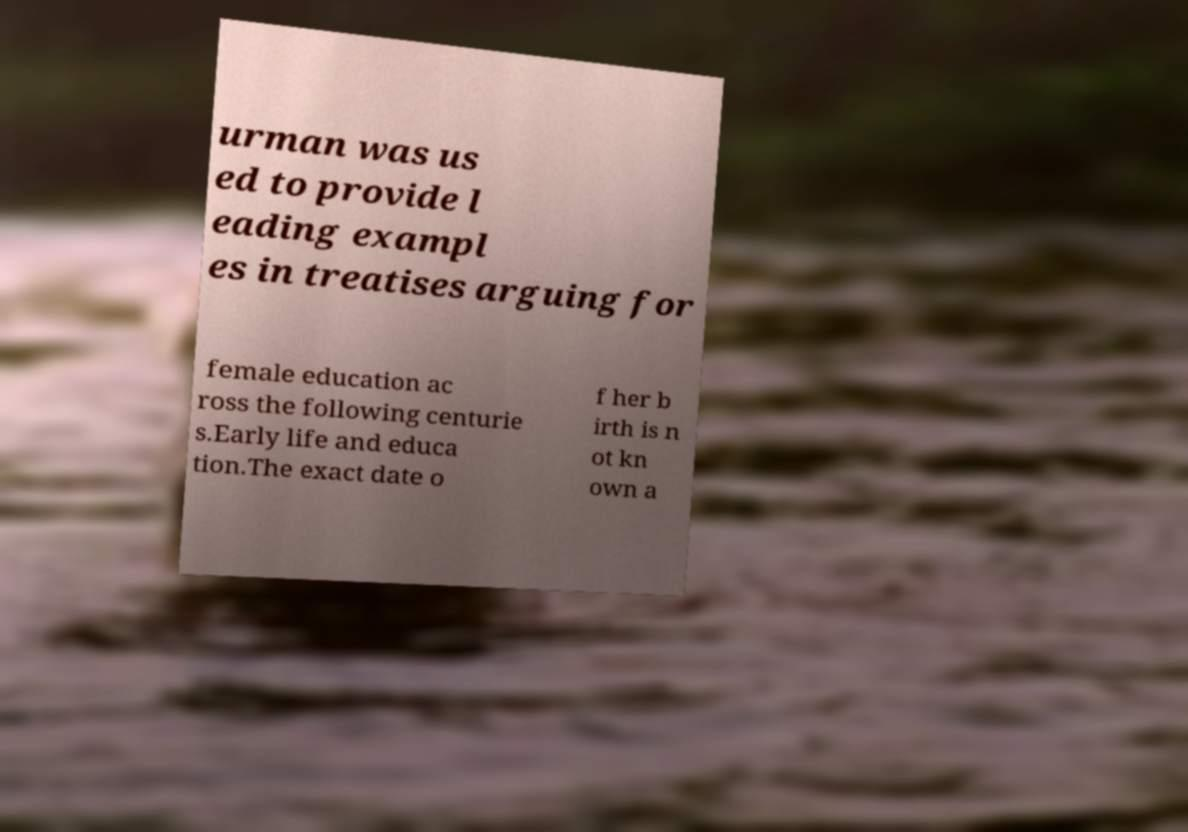Please identify and transcribe the text found in this image. urman was us ed to provide l eading exampl es in treatises arguing for female education ac ross the following centurie s.Early life and educa tion.The exact date o f her b irth is n ot kn own a 